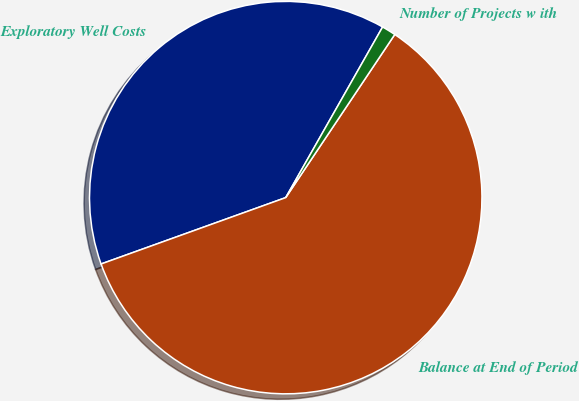Convert chart. <chart><loc_0><loc_0><loc_500><loc_500><pie_chart><fcel>Exploratory Well Costs<fcel>Balance at End of Period<fcel>Number of Projects w ith<nl><fcel>38.71%<fcel>60.13%<fcel>1.16%<nl></chart> 